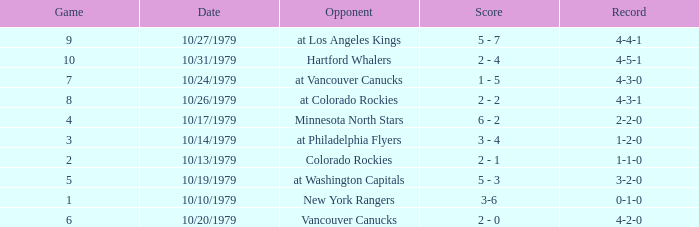Who is the opponent before game 5 with a 0-1-0 record? New York Rangers. 